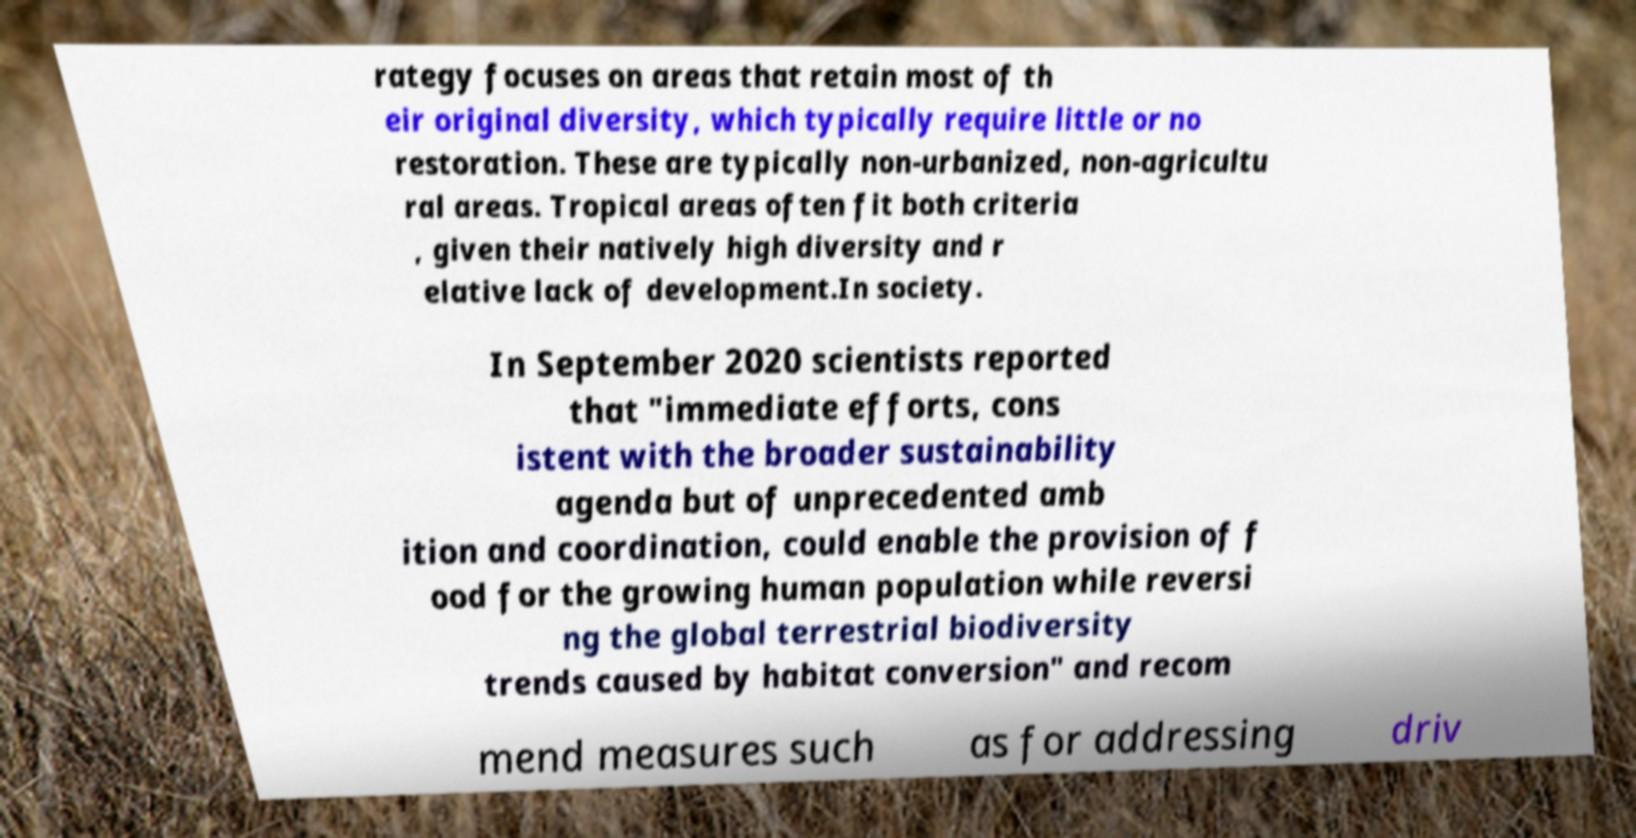Can you accurately transcribe the text from the provided image for me? rategy focuses on areas that retain most of th eir original diversity, which typically require little or no restoration. These are typically non-urbanized, non-agricultu ral areas. Tropical areas often fit both criteria , given their natively high diversity and r elative lack of development.In society. In September 2020 scientists reported that "immediate efforts, cons istent with the broader sustainability agenda but of unprecedented amb ition and coordination, could enable the provision of f ood for the growing human population while reversi ng the global terrestrial biodiversity trends caused by habitat conversion" and recom mend measures such as for addressing driv 